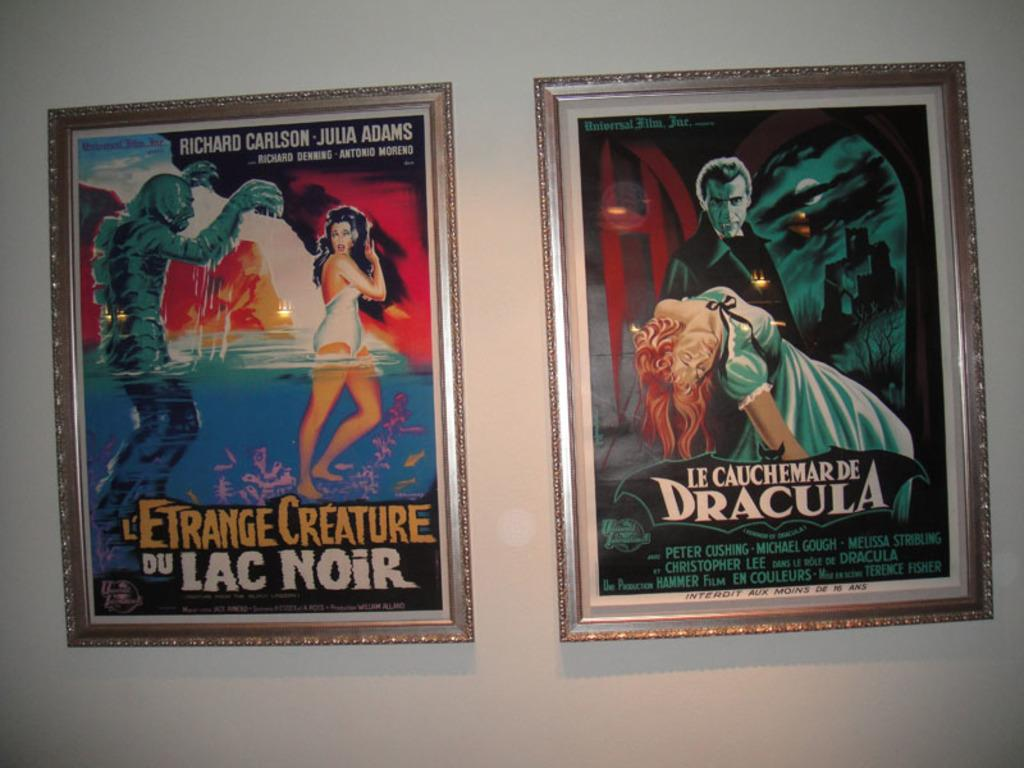<image>
Describe the image concisely. Two movie posters on a wall including one that says Dracula. 